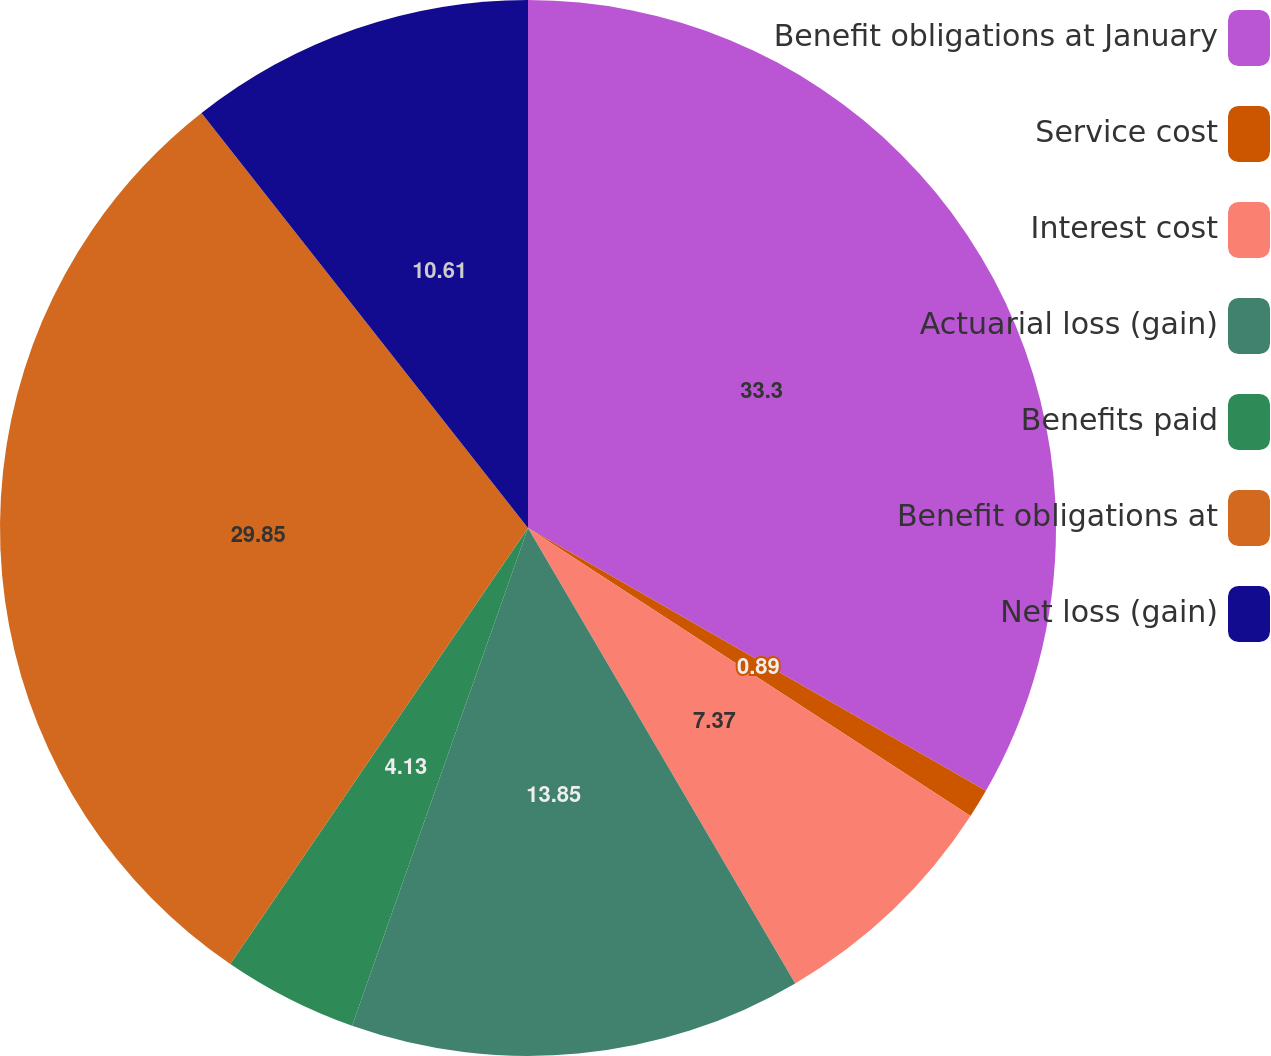<chart> <loc_0><loc_0><loc_500><loc_500><pie_chart><fcel>Benefit obligations at January<fcel>Service cost<fcel>Interest cost<fcel>Actuarial loss (gain)<fcel>Benefits paid<fcel>Benefit obligations at<fcel>Net loss (gain)<nl><fcel>33.29%<fcel>0.89%<fcel>7.37%<fcel>13.85%<fcel>4.13%<fcel>29.85%<fcel>10.61%<nl></chart> 